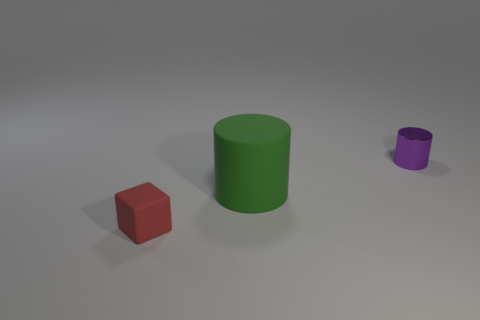Do the large matte thing and the tiny purple shiny thing have the same shape? Indeed, they do. Both the large matte green object, which is a cylinder, and the tiny purple shiny object, which appears to be a smaller cylinder, share the same geometric shape. Despite the difference in size, texture, and color, the fundamental structure of their shapes are the same, having circular bases and straight parallel sides. 